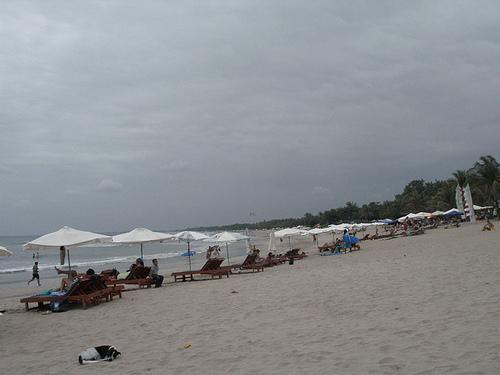How many birds are in the closest spot?
Give a very brief answer. 0. How many toilets are there?
Give a very brief answer. 0. How many birds are standing in this field?
Give a very brief answer. 0. 